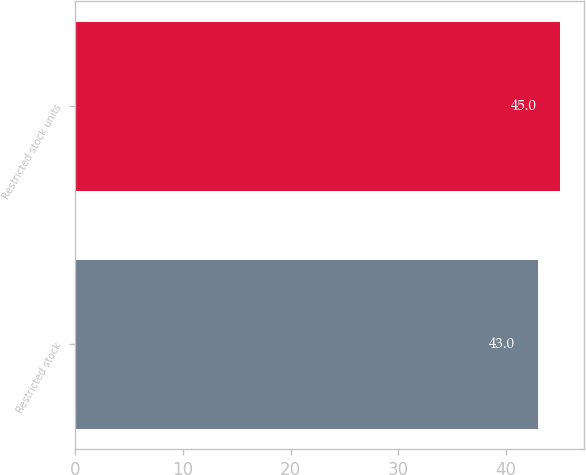Convert chart to OTSL. <chart><loc_0><loc_0><loc_500><loc_500><bar_chart><fcel>Restricted stock<fcel>Restricted stock units<nl><fcel>43<fcel>45<nl></chart> 